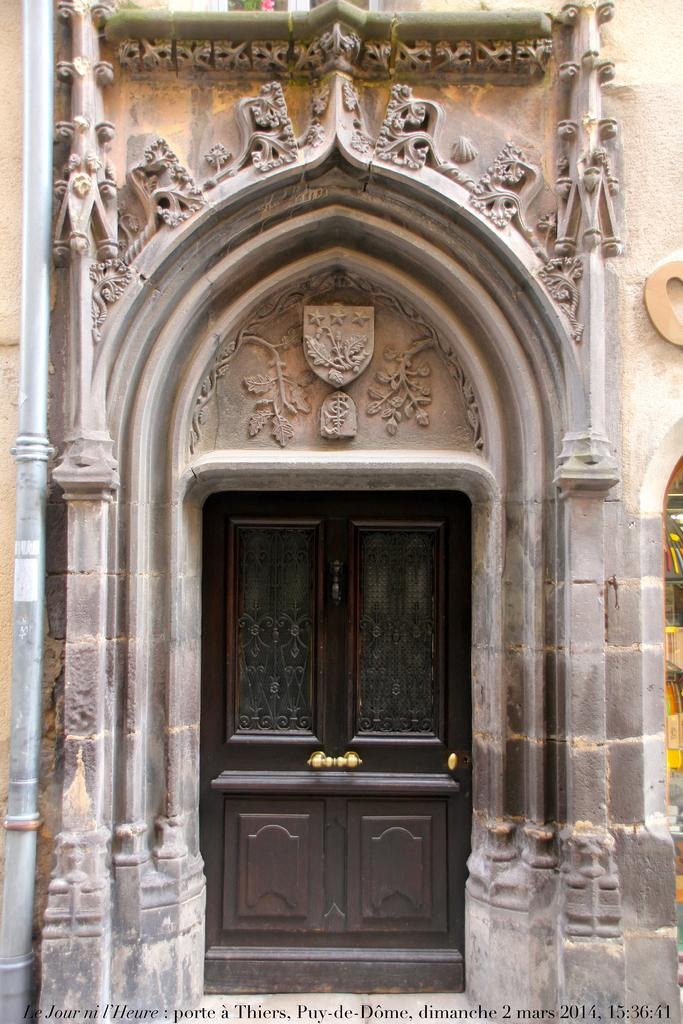What type of structure can be seen in the image? There is a wall in the image. What is the color of the door on the wall? The door is black in color. Are there any decorative elements on the wall? Yes, there are designs on the wall in the image. Can you tell me how many aunts are standing next to the wall in the image? There are no people, including aunts, present in the image; it only features a wall with a black door and designs. What type of spark can be seen coming from the designs on the wall? There is no spark present in the image; the designs on the wall are not emitting any light or energy. 